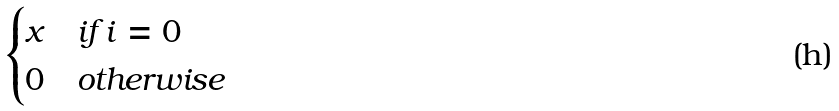<formula> <loc_0><loc_0><loc_500><loc_500>\begin{cases} x & \text {if $i=0$} \\ 0 & \text {otherwise} \end{cases}</formula> 